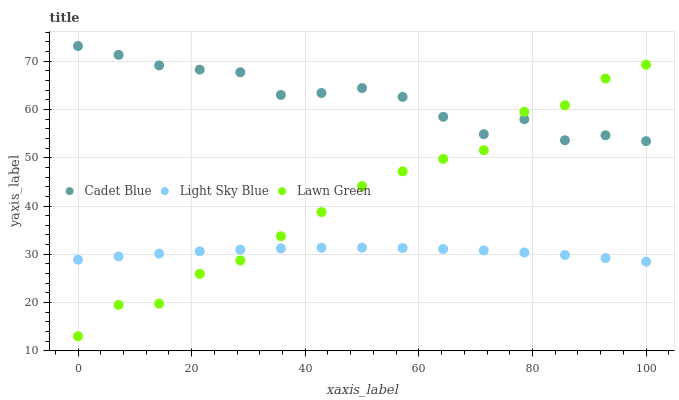Does Light Sky Blue have the minimum area under the curve?
Answer yes or no. Yes. Does Cadet Blue have the maximum area under the curve?
Answer yes or no. Yes. Does Cadet Blue have the minimum area under the curve?
Answer yes or no. No. Does Light Sky Blue have the maximum area under the curve?
Answer yes or no. No. Is Light Sky Blue the smoothest?
Answer yes or no. Yes. Is Lawn Green the roughest?
Answer yes or no. Yes. Is Cadet Blue the smoothest?
Answer yes or no. No. Is Cadet Blue the roughest?
Answer yes or no. No. Does Lawn Green have the lowest value?
Answer yes or no. Yes. Does Light Sky Blue have the lowest value?
Answer yes or no. No. Does Cadet Blue have the highest value?
Answer yes or no. Yes. Does Light Sky Blue have the highest value?
Answer yes or no. No. Is Light Sky Blue less than Cadet Blue?
Answer yes or no. Yes. Is Cadet Blue greater than Light Sky Blue?
Answer yes or no. Yes. Does Lawn Green intersect Light Sky Blue?
Answer yes or no. Yes. Is Lawn Green less than Light Sky Blue?
Answer yes or no. No. Is Lawn Green greater than Light Sky Blue?
Answer yes or no. No. Does Light Sky Blue intersect Cadet Blue?
Answer yes or no. No. 